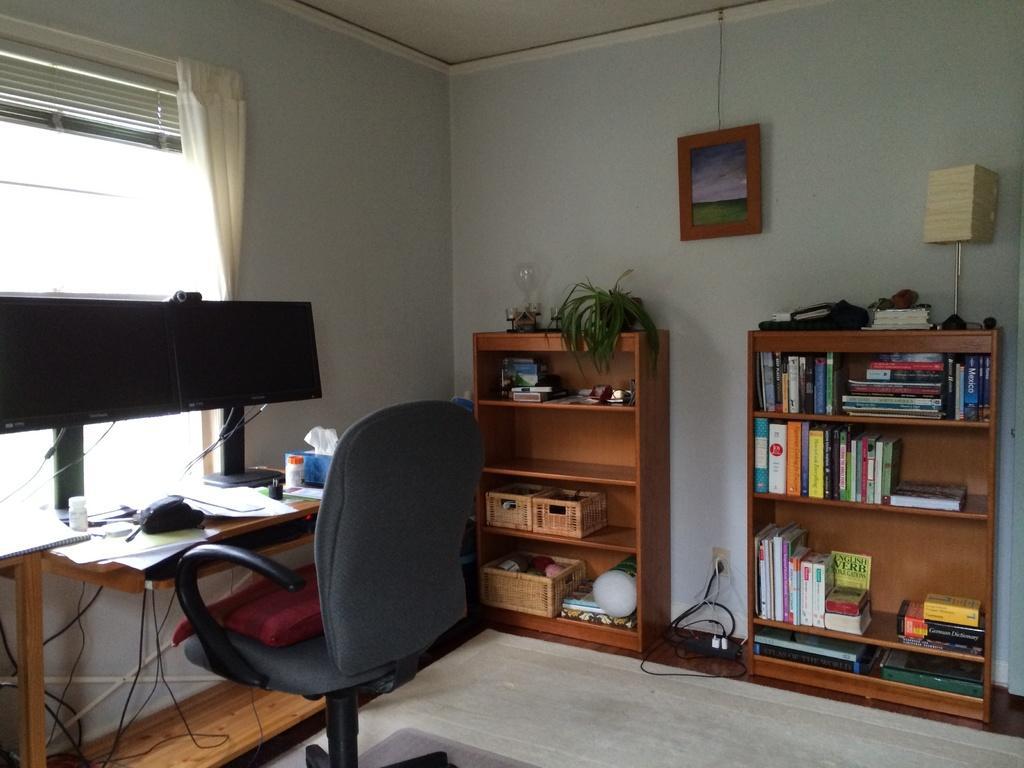Please provide a concise description of this image. There is a chair in front of a table which has two desktops and some papers on it and there is a bookshelf in the right corner. 